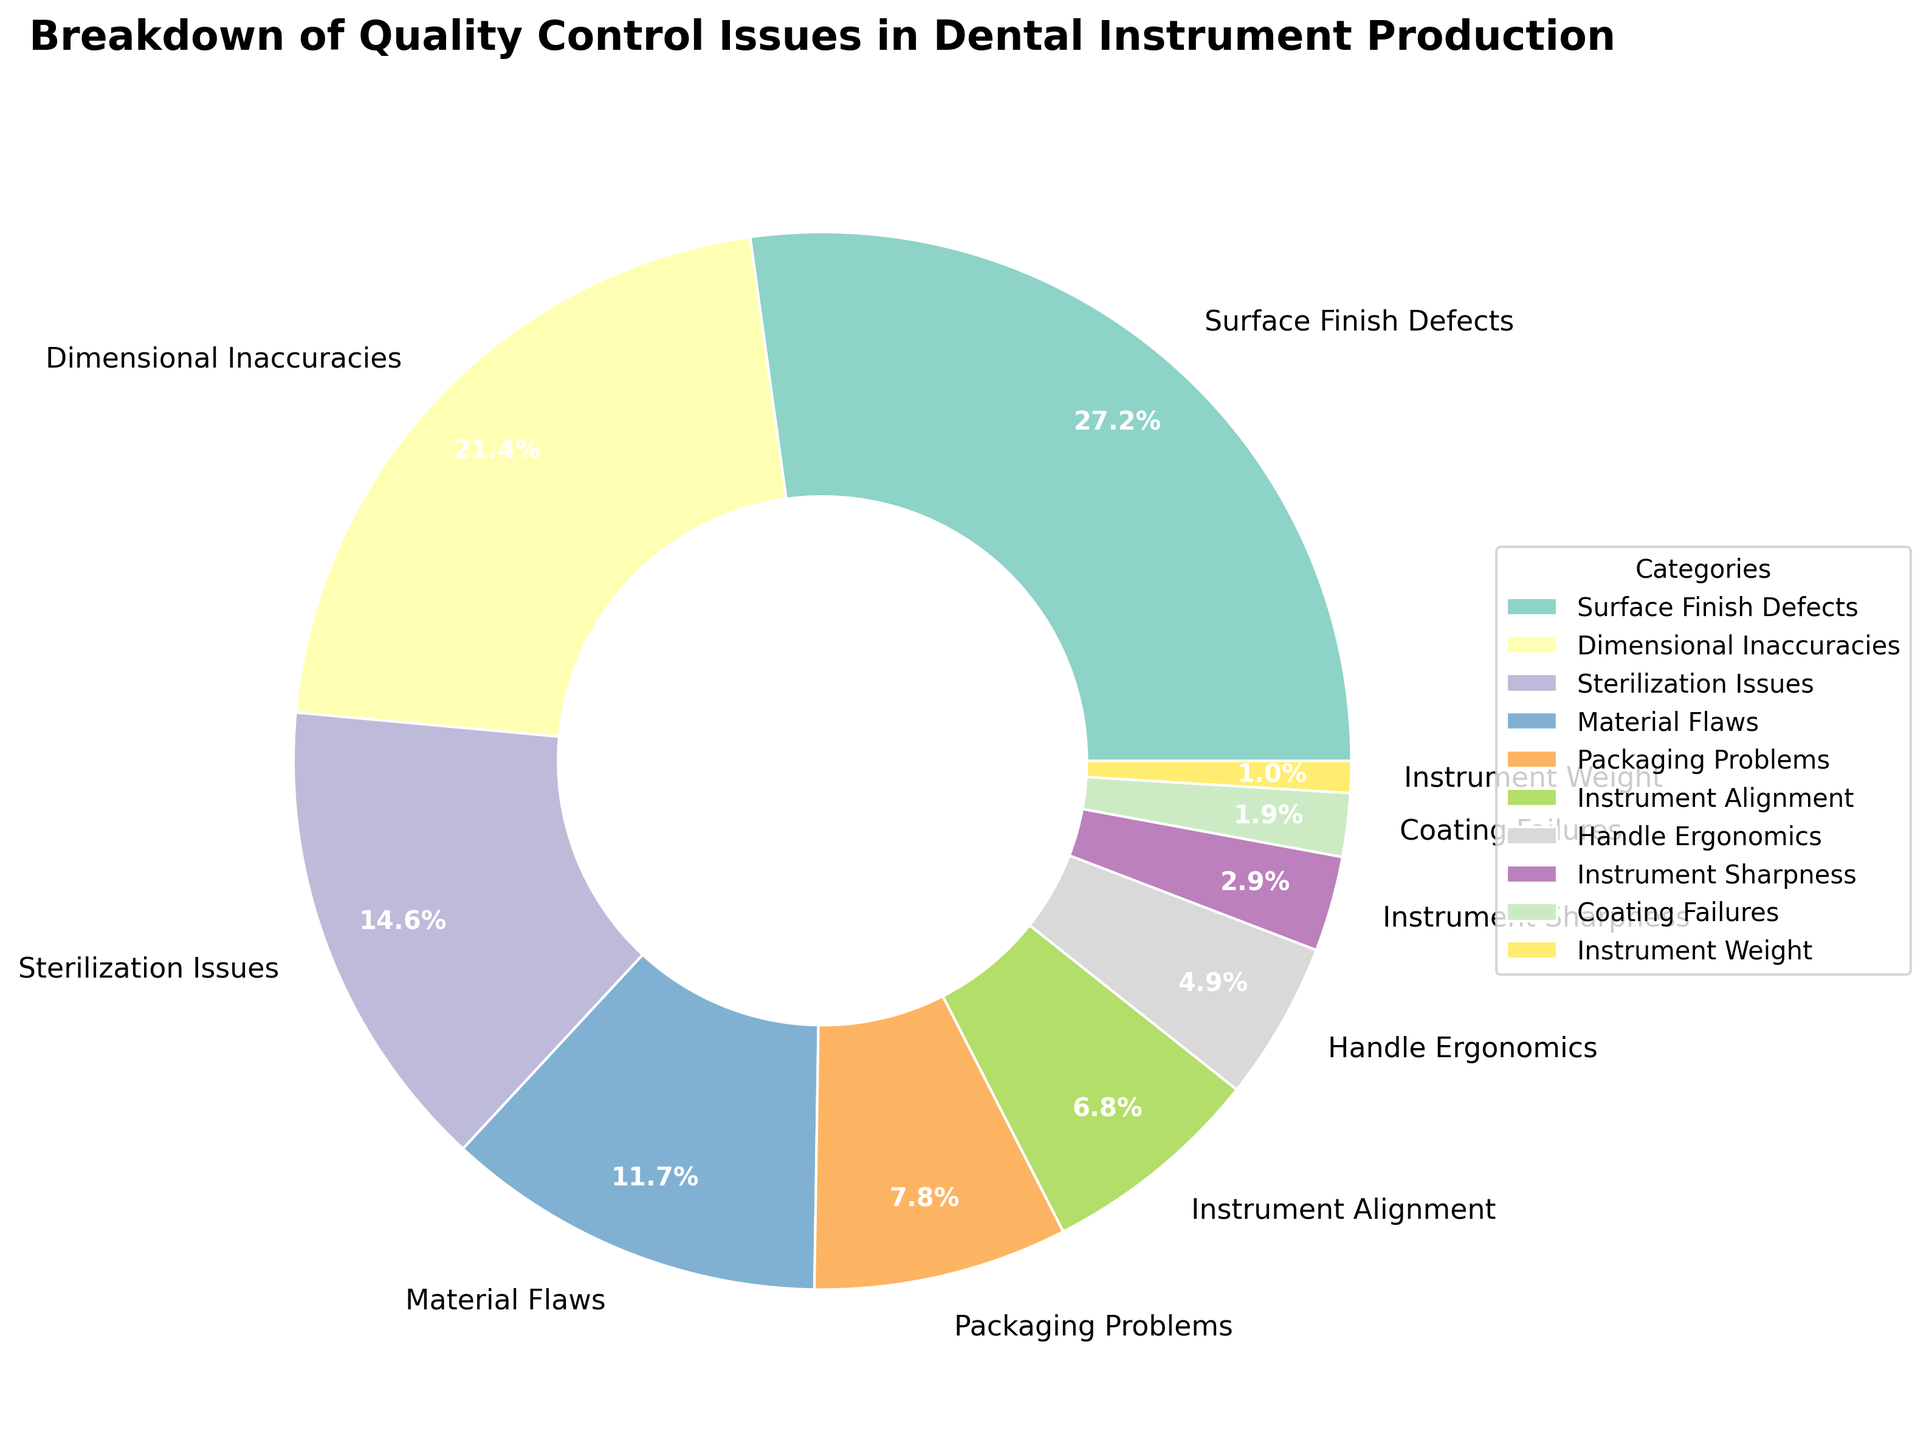Which category has the highest percentage of quality control issues? The category with the highest percentage of quality control issues is the one with the largest slice in the pie chart. The chart shows that "Surface Finish Defects" occupy the largest slice.
Answer: Surface Finish Defects What is the combined percentage of "Dimensional Inaccuracies" and "Material Flaws"? To find the combined percentage, add the individual percentages of "Dimensional Inaccuracies" (22%) and "Material Flaws" (12%). Therefore, the combined percentage is 22% + 12% = 34%.
Answer: 34% Is the percentage of "Packaging Problems" greater than "Instrument Adjustment"? By comparing the two slices for "Packaging Problems" (8%) and "Instrument Adjustment" (7%), you can see that "Packaging Problems" has a slightly larger percentage.
Answer: Yes Which quality control issue accounts for the smallest percentage of problems? The smallest slice in the pie chart corresponds to the category "Instrument Weight" with 1%.
Answer: Instrument Weight What is the percentage difference between "Sterilization Issues" and "Handle Ergonomics"? Subtract the percentage of "Handle Ergonomics" (5%) from "Sterilization Issues" (15%) to find the difference: 15% - 5% = 10%.
Answer: 10% How does the percentage of "Coating Failures" compare to "Instrument Sharpness"? Compare the slices for "Coating Failures" (2%) and "Instrument Sharpness" (3%). The "Instrument Sharpness" slice is slightly larger.
Answer: Instrument Sharpness is greater Are there more quality control issues related to "Sterilization Issues" or "Dimensional Inaccuracies"? By looking at the chart, the slice for "Dimensional Inaccuracies" (22%) is larger than the slice for "Sterilization Issues" (15%).
Answer: Dimensional Inaccuracies What is the total percentage of quality control issues related to "Instrument Alignment" and "Handle Ergonomics"? Add the percentages of "Instrument Alignment" (7%) and "Handle Ergonomics" (5%) to get the total: 7% + 5% = 12%.
Answer: 12% Which color represents "Material Flaws" in the pie chart? Identify the color in the pie chart that corresponds with "Material Flaws". As per the description, this should be easy to see visually.
Answer: (Nature of the answer depends on the specific color, e.g., green, orange, etc. The actual answer would be based on the specific figure provided.) If "Instrument Sharpness" issues were reduced by 1%, what would the new percentage be? Subtract 1% from the current percentage of "Instrument Sharpness" (3%): 3% - 1% = 2%.
Answer: 2% 